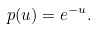<formula> <loc_0><loc_0><loc_500><loc_500>p ( u ) = e ^ { - u } .</formula> 